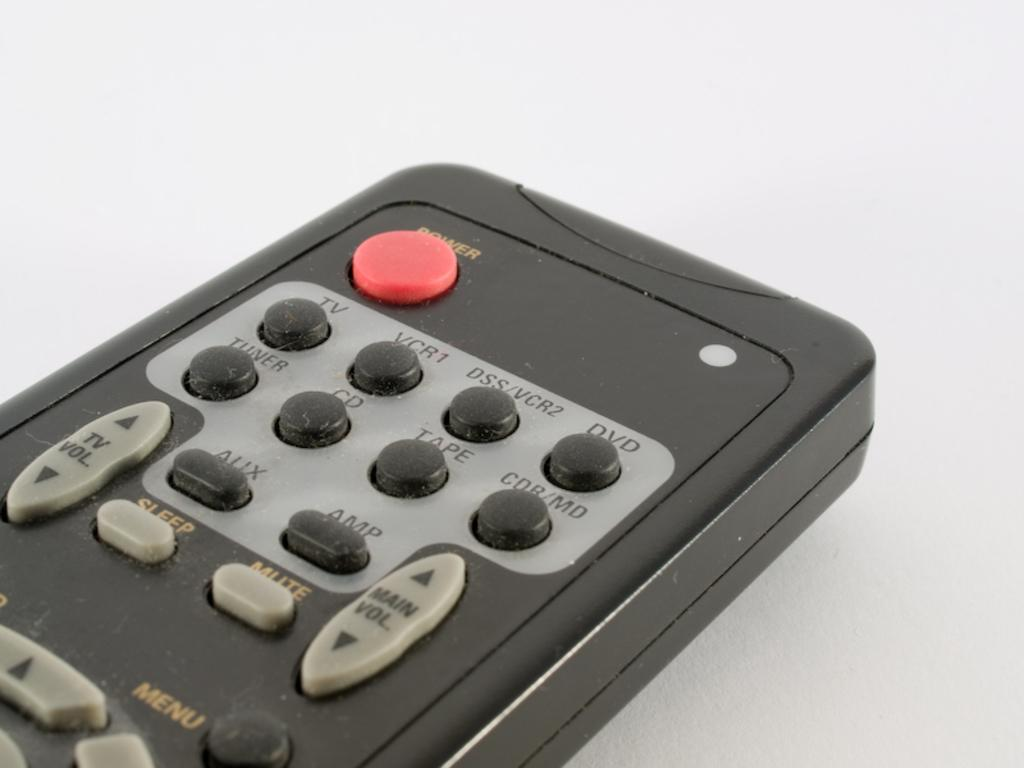<image>
Render a clear and concise summary of the photo. A close up shot of an old remote's power button, and vcr buttons 